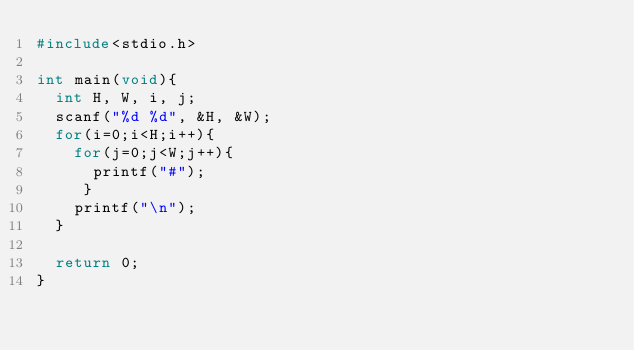Convert code to text. <code><loc_0><loc_0><loc_500><loc_500><_C_>#include<stdio.h>

int main(void){
  int H, W, i, j;
  scanf("%d %d", &H, &W);
  for(i=0;i<H;i++){
    for(j=0;j<W;j++){
      printf("#");
     }
    printf("\n");
  }

  return 0;
}

</code> 